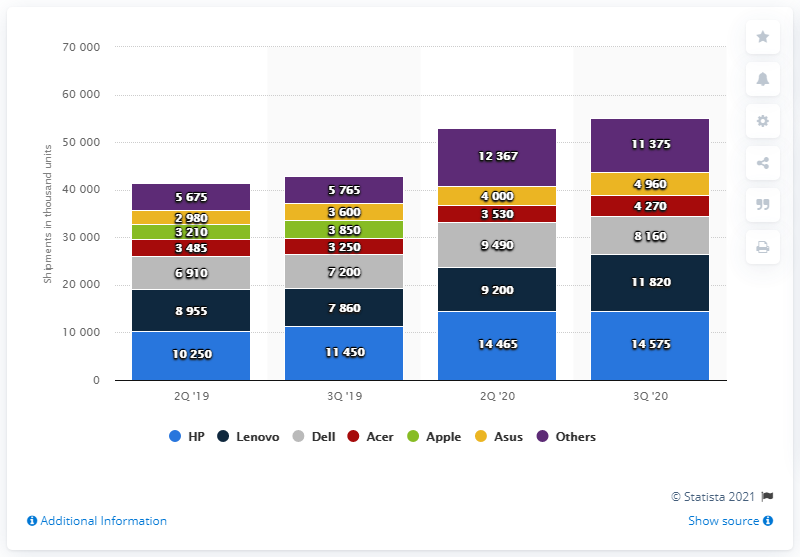Highlight a few significant elements in this photo. The difference between HP in the second quarter of 2019 and the third quarter of 2019, and the second quarter of 2020 and the third quarter of 2020 is 7340000. In the third quarter of 2020, it is expected that 14,575 HP notebook PCs will be shipped. It is estimated that 7 brands are considered totally. In the second quarter of 2019, HP's shipments were 10,250. 